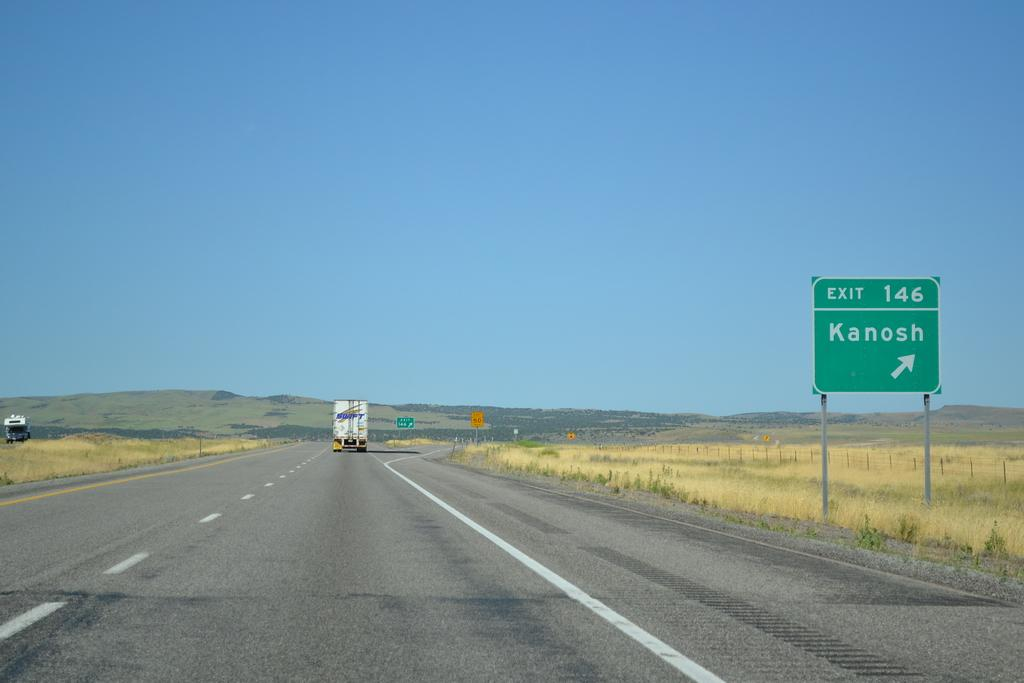<image>
Relay a brief, clear account of the picture shown. A street sign on the side of a highway is pointing to the right, where a town called Kanosh is. 